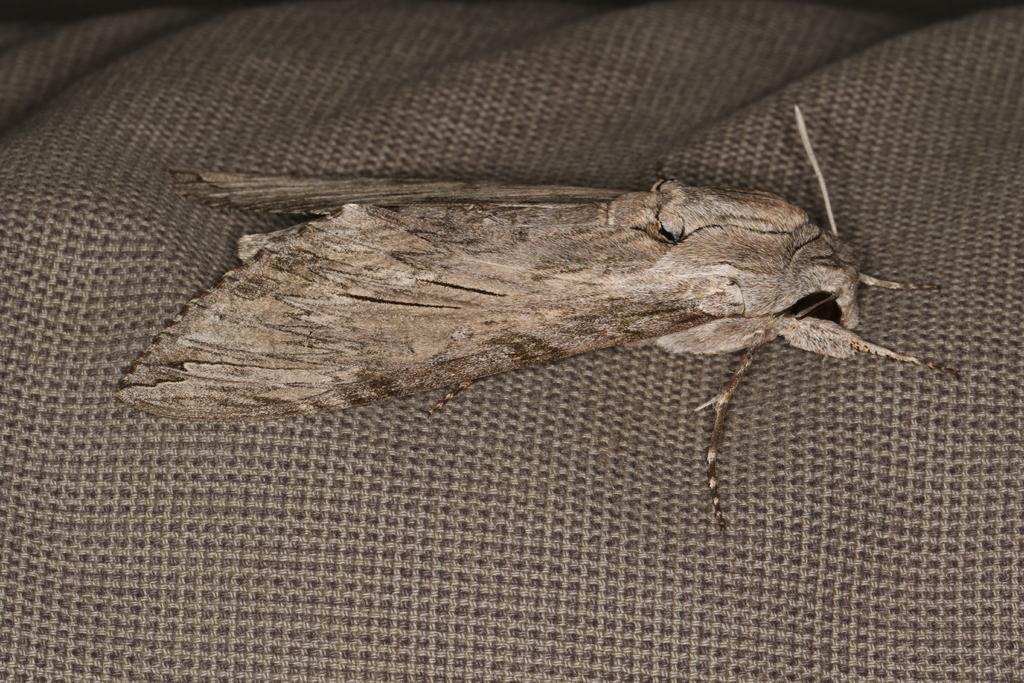Could you give a brief overview of what you see in this image? In the center of the image we can see an insect on the mat. 